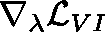Convert formula to latex. <formula><loc_0><loc_0><loc_500><loc_500>\nabla _ { \lambda } \mathcal { L } _ { V I }</formula> 